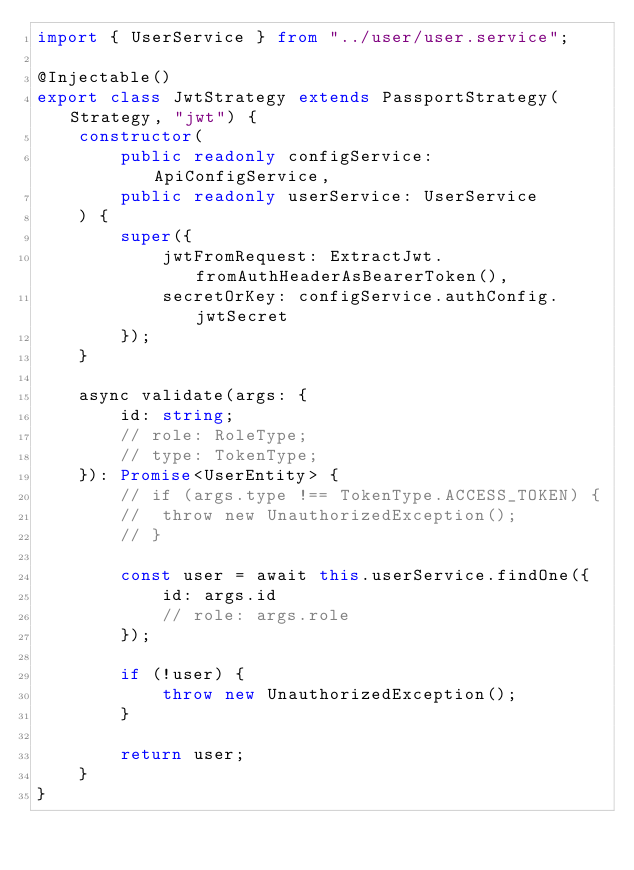<code> <loc_0><loc_0><loc_500><loc_500><_TypeScript_>import { UserService } from "../user/user.service";

@Injectable()
export class JwtStrategy extends PassportStrategy(Strategy, "jwt") {
	constructor(
		public readonly configService: ApiConfigService,
		public readonly userService: UserService
	) {
		super({
			jwtFromRequest: ExtractJwt.fromAuthHeaderAsBearerToken(),
			secretOrKey: configService.authConfig.jwtSecret
		});
	}

	async validate(args: {
		id: string;
		// role: RoleType;
		// type: TokenType;
	}): Promise<UserEntity> {
		// if (args.type !== TokenType.ACCESS_TOKEN) {
		// 	throw new UnauthorizedException();
		// }

		const user = await this.userService.findOne({
			id: args.id
			// role: args.role
		});

		if (!user) {
			throw new UnauthorizedException();
		}

		return user;
	}
}
</code> 